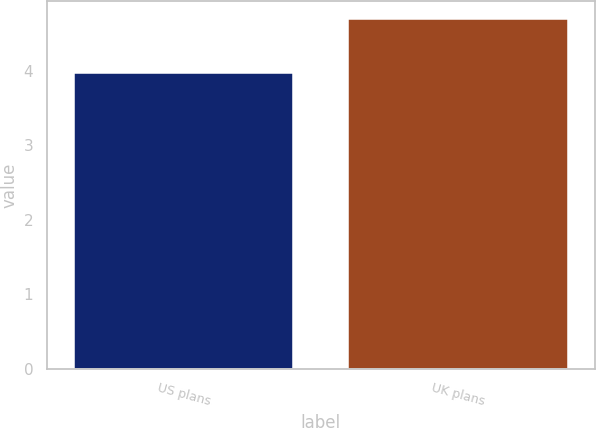Convert chart. <chart><loc_0><loc_0><loc_500><loc_500><bar_chart><fcel>US plans<fcel>UK plans<nl><fcel>3.97<fcel>4.7<nl></chart> 